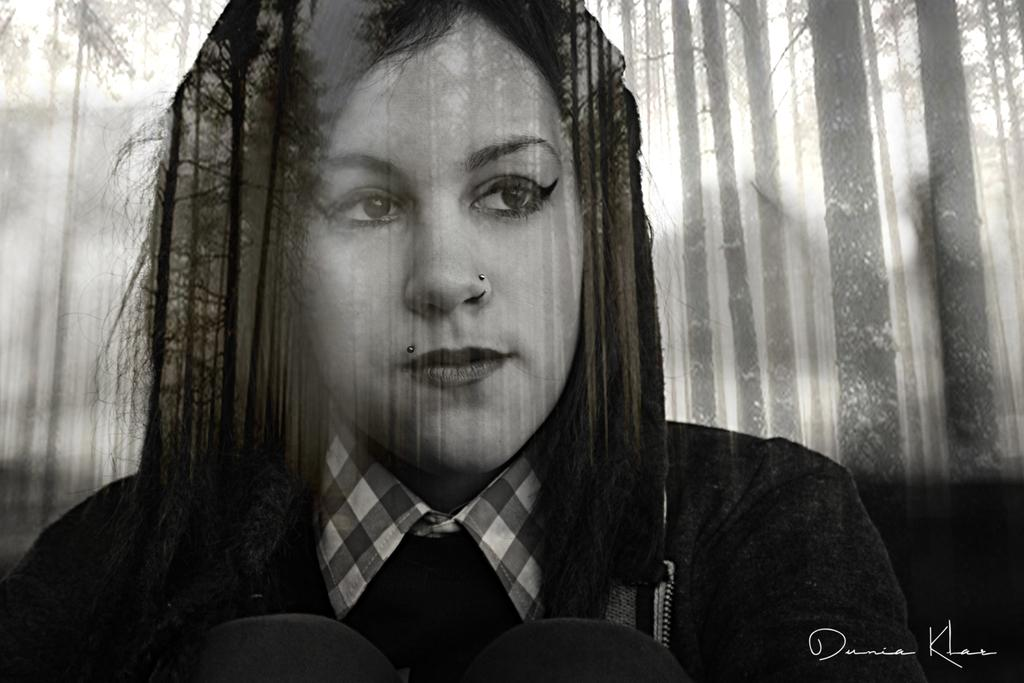What is the color scheme of the image? The image is black and white. Can you describe the main subject in the image? There is a lady in the center of the image. How many zebras can be seen in the image? There are no zebras present in the image. What type of comfort is the lady providing in the image? The image does not provide any information about the lady providing comfort or any specific action she might be taking. 